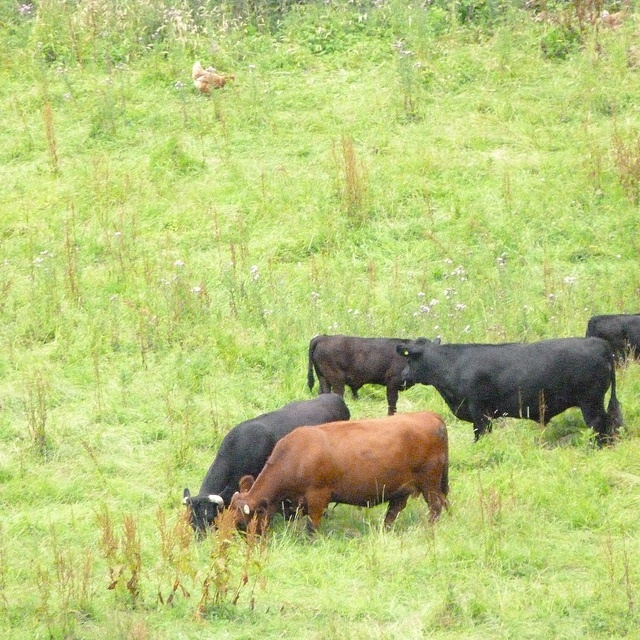Describe the objects in this image and their specific colors. I can see cow in lightgreen, maroon, gray, tan, and brown tones, cow in lightgreen, gray, black, and olive tones, cow in lightgreen, gray, black, and tan tones, cow in lightgreen, gray, black, and darkgreen tones, and cow in lightgreen, gray, and black tones in this image. 